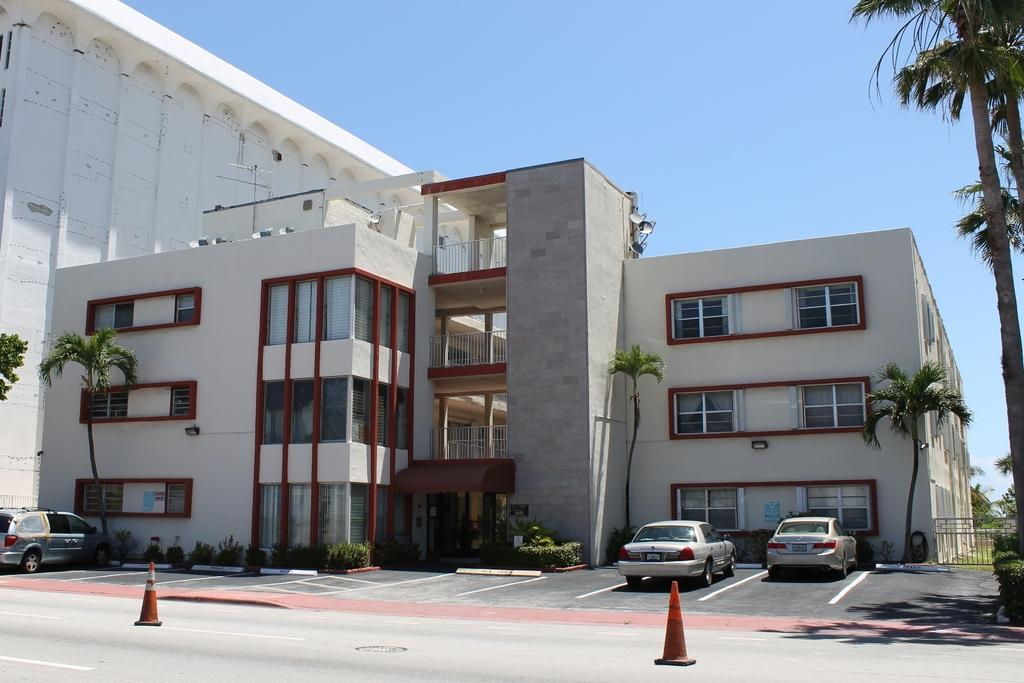How many cars are parked on the path in the image? There are three cars parked on the path in the image. What is placed behind the cars to guide or control traffic? There are cone barriers behind the cars. What type of natural elements can be seen in front of the vehicles? Trees and plants are visible in front of the vehicles. What structure is located in front of the vehicles? There is a building in front of the vehicles. What part of the natural environment is visible in the image? The sky is visible in the image. What type of farm animals can be seen grazing in the aftermath of the image? There is no farm or aftermath present in the image; it features parked cars, cone barriers, trees, plants, a building, and the sky. 